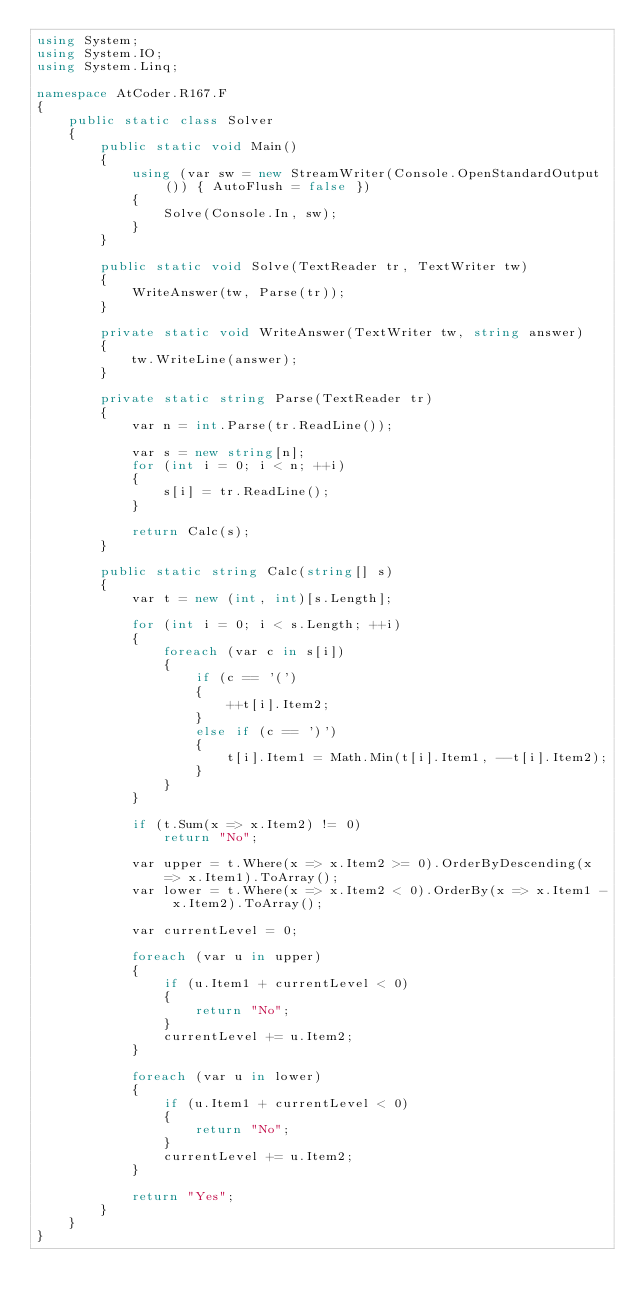<code> <loc_0><loc_0><loc_500><loc_500><_C#_>using System;
using System.IO;
using System.Linq;

namespace AtCoder.R167.F
{
    public static class Solver
    {
        public static void Main()
        {
            using (var sw = new StreamWriter(Console.OpenStandardOutput()) { AutoFlush = false })
            {
                Solve(Console.In, sw);
            }
        }

        public static void Solve(TextReader tr, TextWriter tw)
        {
            WriteAnswer(tw, Parse(tr));
        }

        private static void WriteAnswer(TextWriter tw, string answer)
        {
            tw.WriteLine(answer);
        }

        private static string Parse(TextReader tr)
        {
            var n = int.Parse(tr.ReadLine());

            var s = new string[n];
            for (int i = 0; i < n; ++i)
            {
                s[i] = tr.ReadLine();
            }
            
            return Calc(s);
        }

        public static string Calc(string[] s)
        {
            var t = new (int, int)[s.Length];

            for (int i = 0; i < s.Length; ++i)
            {
                foreach (var c in s[i])
                {
                    if (c == '(')
                    {
                        ++t[i].Item2;
                    }
                    else if (c == ')')
                    {
                        t[i].Item1 = Math.Min(t[i].Item1, --t[i].Item2);
                    }
                }
            }

            if (t.Sum(x => x.Item2) != 0)
                return "No";

            var upper = t.Where(x => x.Item2 >= 0).OrderByDescending(x => x.Item1).ToArray();
            var lower = t.Where(x => x.Item2 < 0).OrderBy(x => x.Item1 - x.Item2).ToArray();

            var currentLevel = 0;

            foreach (var u in upper)
            {
                if (u.Item1 + currentLevel < 0)
                {
                    return "No";
                }
                currentLevel += u.Item2;
            }

            foreach (var u in lower)
            {
                if (u.Item1 + currentLevel < 0)
                {
                    return "No";
                }
                currentLevel += u.Item2;
            }

            return "Yes";
        }
    }
}
</code> 